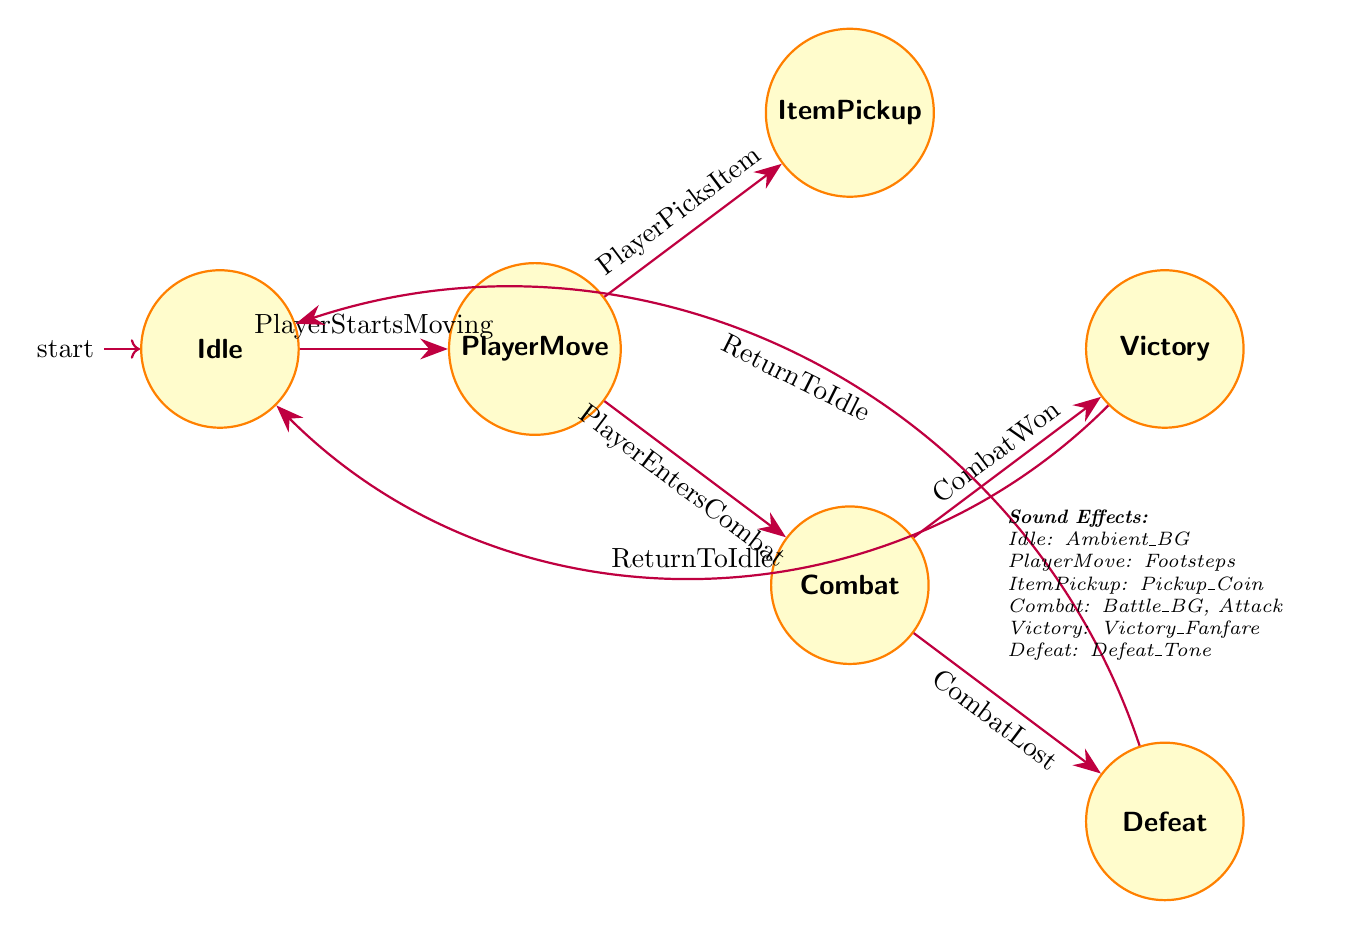How many states are there in the diagram? The diagram lists six distinct states: Idle, PlayerMove, ItemPickup, Combat, Victory, and Defeat. By counting these states, we find there are a total of six.
Answer: 6 What is the sound effect associated with the ItemPickup state? The ItemPickup state specifies the sound effect "Pickup_Coin", which indicates the sound played when an item is collected.
Answer: Pickup_Coin Which state do players enter after defeating an enemy? According to the transitions, if players win a combat, they proceed to the Victory state. This is indicated by the "CombatWon" event leading to this state.
Answer: Victory How many transitions are there leading from the Combat state? The diagram shows two transitions leaving the Combat state: one for "CombatWon" leading to Victory and another for "CombatLost" leading to Defeat. Therefore, there are two transitions.
Answer: 2 What sound effect is played when the player is defeated? In the Defeat state, the sound effect specified is "Defeat_Tone", signaling the player's failure. This is explicitly stated in the actions of the Defeat state.
Answer: Defeat_Tone If a player picks an item while moving, what sound effect will be played? When a player transitions from PlayerMove to ItemPickup due to the event "PlayerPicksItem", the action associated with the ItemPickup state specifies the sound effect "Pickup_Coin". Thus, this sound effect will be played.
Answer: Pickup_Coin What event causes the transition from Idle to PlayerMove? The transition from Idle to PlayerMove occurs when the event "PlayerStartsMoving" is triggered. This is clearly defined in the transition relationships of the diagram.
Answer: PlayerStartsMoving Which sound effect is played during the Combat state? The Combat state has two specified sound effects: "Battle_BG" for background music and "Attack" for the player's attack move. Both sound effects will play while in this state.
Answer: Battle_BG, Attack 